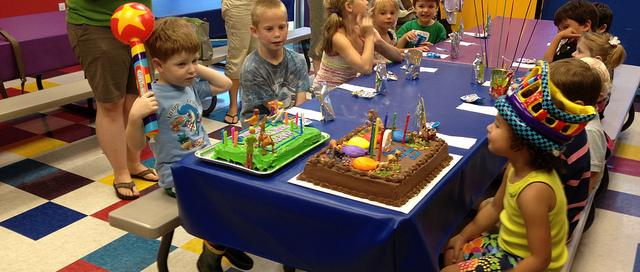Where is this party taking place?

Choices:
A) formal restaurant
B) home
C) kid's restaurant
D) club kid's restaurant 